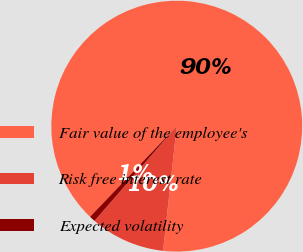<chart> <loc_0><loc_0><loc_500><loc_500><pie_chart><fcel>Fair value of the employee's<fcel>Risk free interest rate<fcel>Expected volatility<nl><fcel>89.59%<fcel>9.64%<fcel>0.77%<nl></chart> 